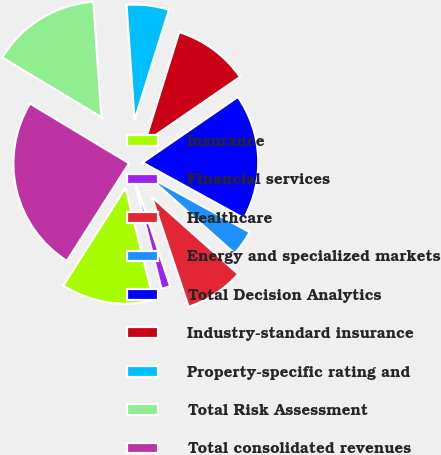Convert chart to OTSL. <chart><loc_0><loc_0><loc_500><loc_500><pie_chart><fcel>Insurance<fcel>Financial services<fcel>Healthcare<fcel>Energy and specialized markets<fcel>Total Decision Analytics<fcel>Industry-standard insurance<fcel>Property-specific rating and<fcel>Total Risk Assessment<fcel>Total consolidated revenues<nl><fcel>12.93%<fcel>1.25%<fcel>8.26%<fcel>3.59%<fcel>17.6%<fcel>10.59%<fcel>5.92%<fcel>15.26%<fcel>24.6%<nl></chart> 